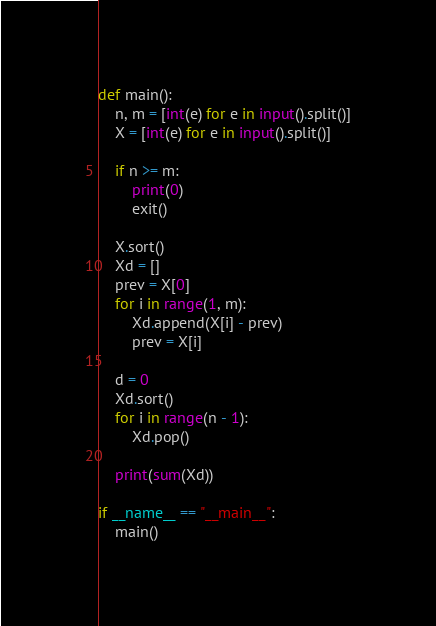Convert code to text. <code><loc_0><loc_0><loc_500><loc_500><_Python_>def main():
    n, m = [int(e) for e in input().split()]
    X = [int(e) for e in input().split()]

    if n >= m:
        print(0)
        exit()

    X.sort()
    Xd = []
    prev = X[0]
    for i in range(1, m):
        Xd.append(X[i] - prev)
        prev = X[i]

    d = 0
    Xd.sort()
    for i in range(n - 1):
        Xd.pop()

    print(sum(Xd))

if __name__ == "__main__":
    main()
</code> 